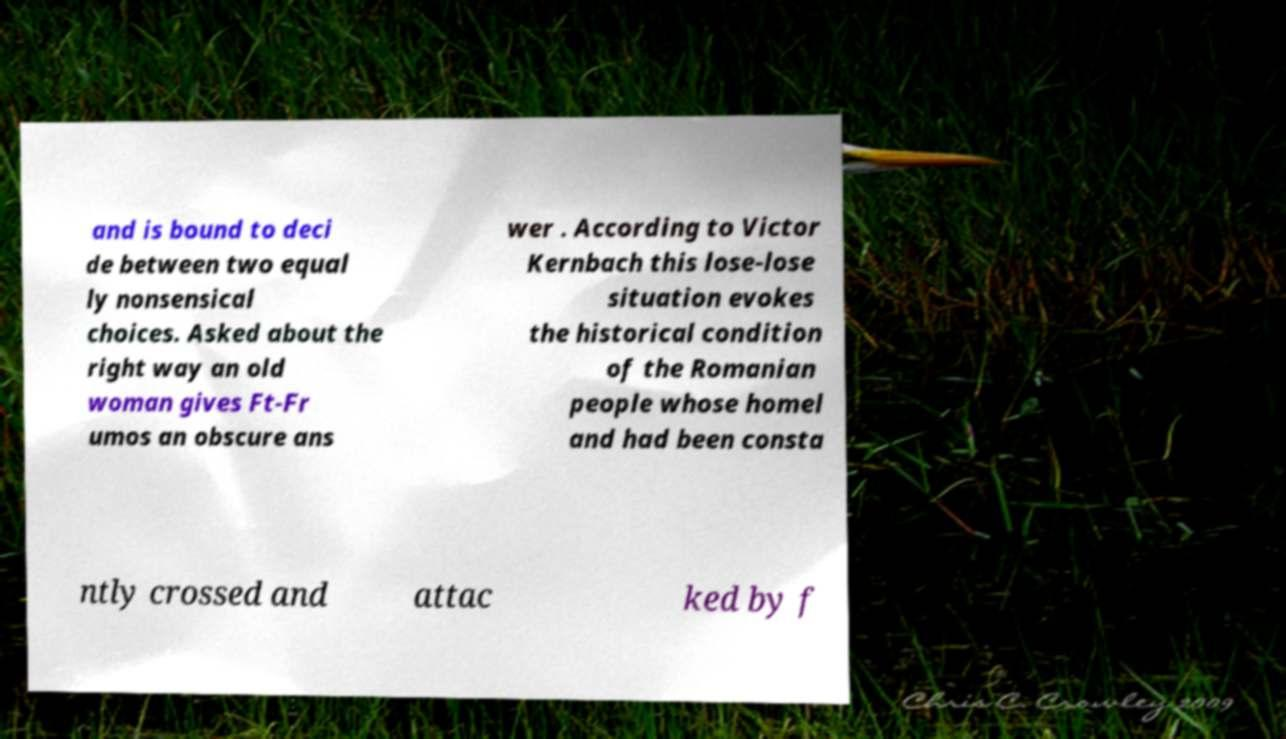Could you assist in decoding the text presented in this image and type it out clearly? and is bound to deci de between two equal ly nonsensical choices. Asked about the right way an old woman gives Ft-Fr umos an obscure ans wer . According to Victor Kernbach this lose-lose situation evokes the historical condition of the Romanian people whose homel and had been consta ntly crossed and attac ked by f 